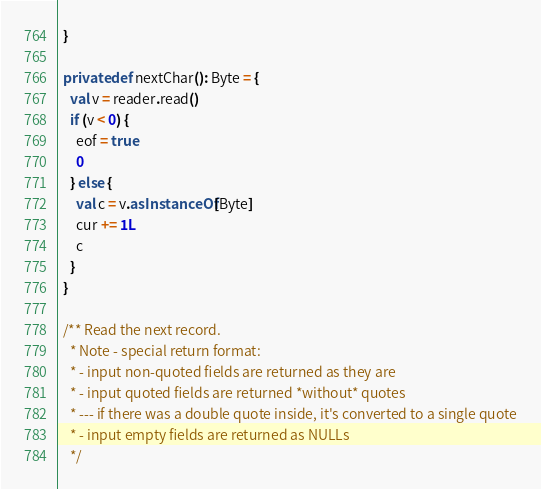<code> <loc_0><loc_0><loc_500><loc_500><_Scala_>  }

  private def nextChar(): Byte = {
    val v = reader.read()
    if (v < 0) {
      eof = true
      0
    } else {
      val c = v.asInstanceOf[Byte]
      cur += 1L
      c
    }
  }

  /** Read the next record.
    * Note - special return format:
    * - input non-quoted fields are returned as they are
    * - input quoted fields are returned *without* quotes
    * --- if there was a double quote inside, it's converted to a single quote
    * - input empty fields are returned as NULLs
    */</code> 